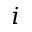<formula> <loc_0><loc_0><loc_500><loc_500>i</formula> 